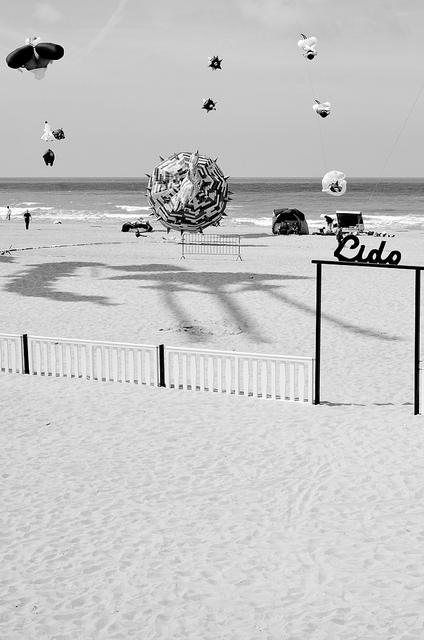Is the photo colored?
Be succinct. No. Are these kites?
Short answer required. Yes. Where is the fence?
Give a very brief answer. Beach. 